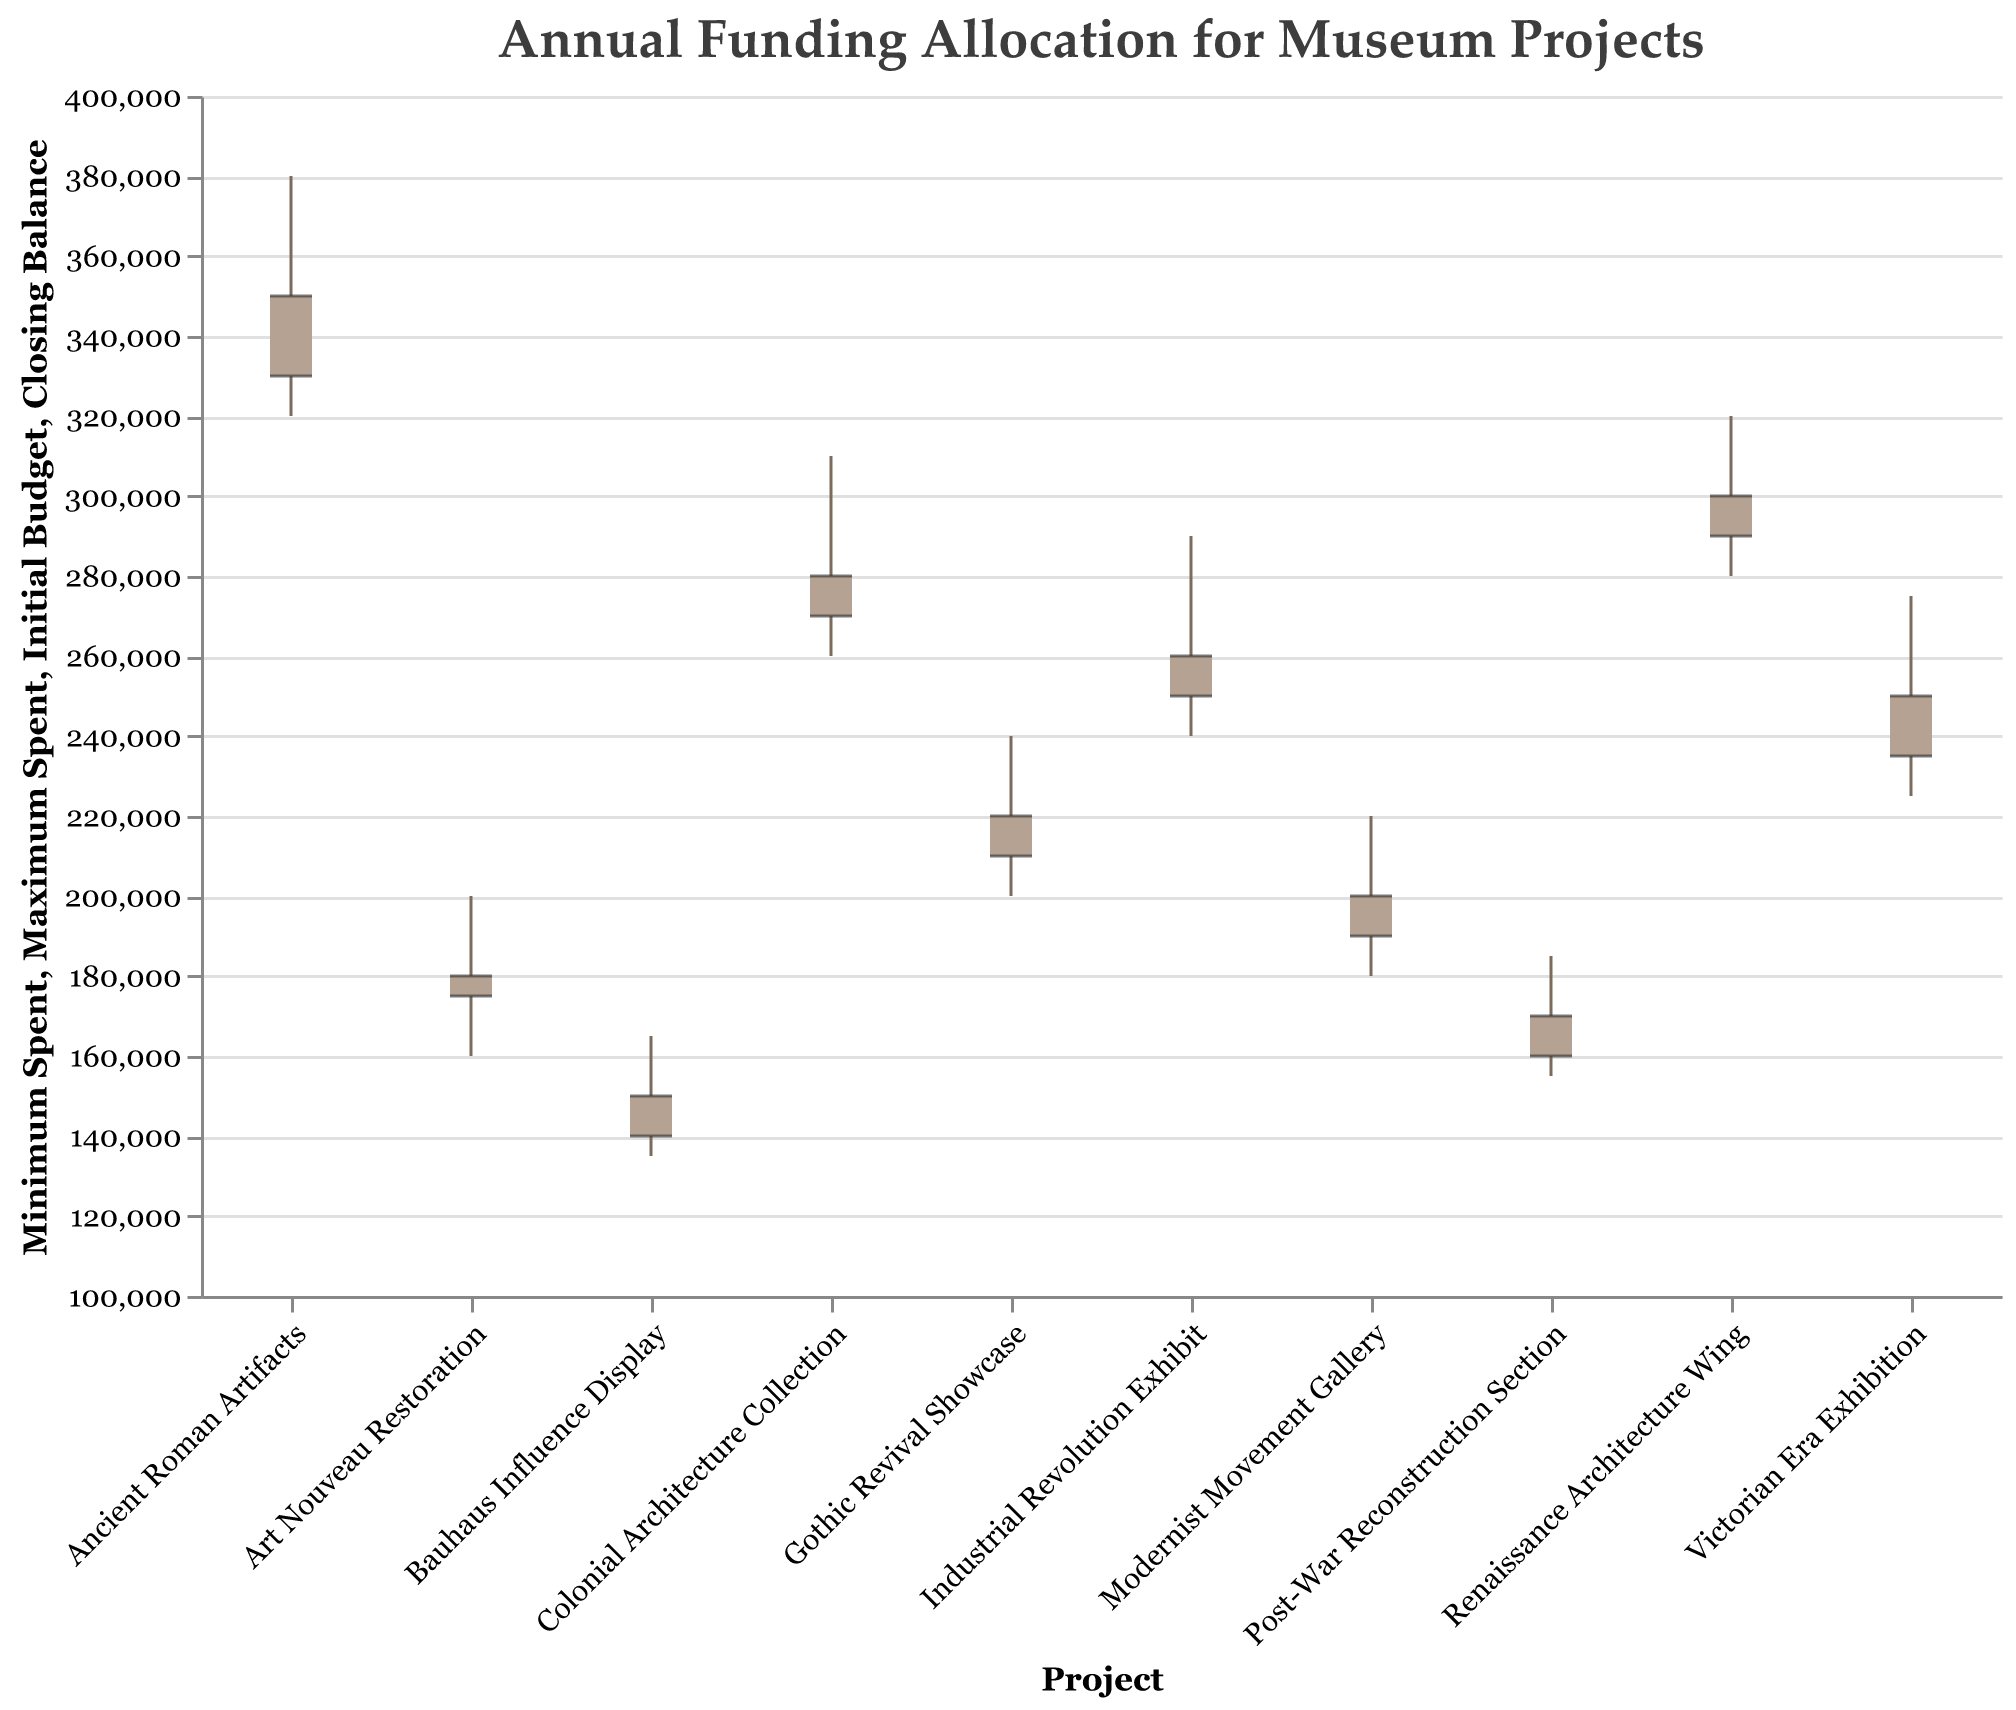What is the title of the figure? The title is displayed prominently at the top of the figure and reads "Annual Funding Allocation for Museum Projects"
Answer: Annual Funding Allocation for Museum Projects Which project has the highest initial budget? The height of the initial budget bar (left-most segment) for the "Ancient Roman Artifacts" project is the tallest compared to others
Answer: Ancient Roman Artifacts Which project has the minimum closing balance? The lowest closing balance bar (right-most segment) appears for the "Bauhaus Influence Display" project
Answer: Bauhaus Influence Display How many projects have an initial budget of 250,000 or more? Count the number of bars where the left-most segment (initial budget) is 250,000 or above. These are: Victorian Era Exhibition, Renaissance Architecture Wing, Colonial Architecture Collection, Ancient Roman Artifacts, and Industrial Revolution Exhibit
Answer: 5 Which project saw the biggest drop from maximum spent to closing balance? Calculate the drop for each project by subtracting the closing balance from the maximum spent and compare to find the largest difference. "Victorian Era Exhibition" = 275,000 - 235,000 = 40,000
Answer: Victorian Era Exhibition Compare the initial budget of the Victorian Era Exhibition and the Renaissance Architecture Wing. Which one was higher? Compare the left-most segments of both projects. "Victorian Era Exhibition" starts at 250,000, "Renaissance Architecture Wing" starts at 300,000
Answer: Renaissance Architecture Wing Which project had the narrowest range between its minimum spent and maximum spent? Calculate the range for each project by subtracting the minimum spent from the maximum spent. "Post-War Reconstruction Section" = 185,000 - 155,000 = 30,000
Answer: Post-War Reconstruction Section Did any project end with a closing balance higher than its initial budget? Look for any projects where the right-most segment (closing balance) is higher than the left-most segment (initial budget). None of the projects have a closing balance that exceeds their initial budget
Answer: No For the "Industrial Revolution Exhibit," what is the difference between the initial budget and the closing balance? Subtract the closing balance from the initial budget for "Industrial Revolution Exhibit": 260,000 - 250,000 = 10,000
Answer: 10,000 What was the maximum amount spent for the "Art Nouveau Restoration" project? Refer to the highest point on the bar representing the "Art Nouveau Restoration" project, which is at 200,000
Answer: 200,000 